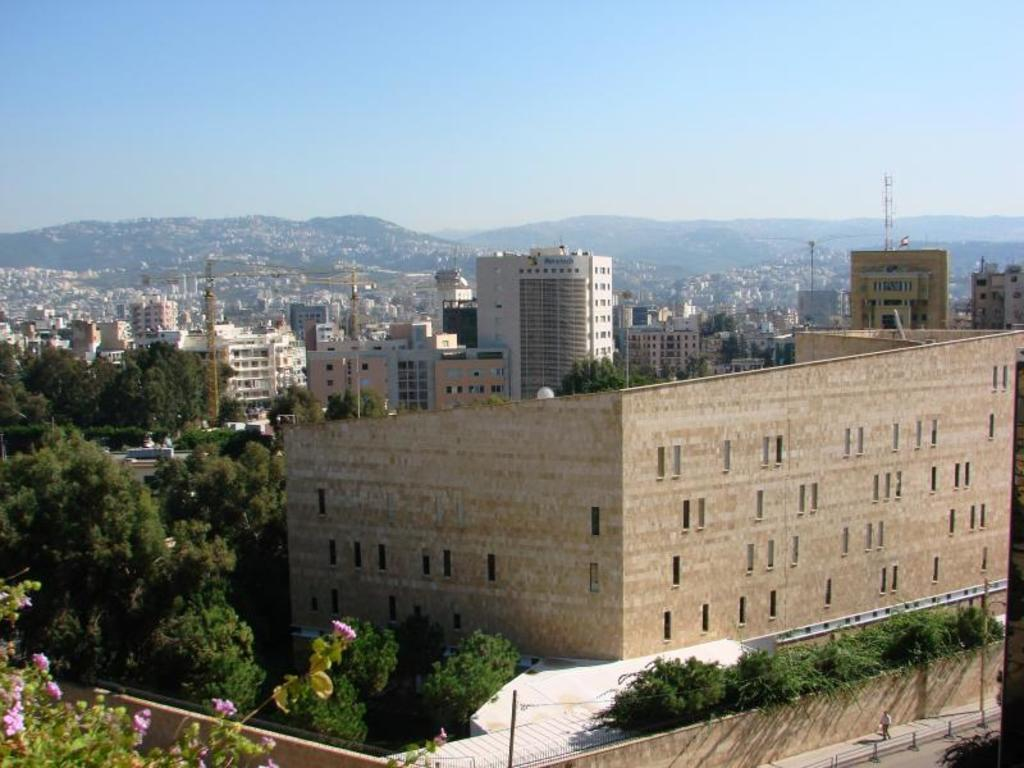What type of structures can be seen in the image? There are buildings in the image. What other elements are present in the image besides buildings? There are plants and trees in the image. Can you describe the trees in the background of the image? Yes, there are trees in the background of the image. What is visible at the top of the image? The sky is visible at the top of the image. Where are the chickens located in the image? There are no chickens present in the image. What type of crack can be seen on the library's wall in the image? There is no library or crack present in the image. 